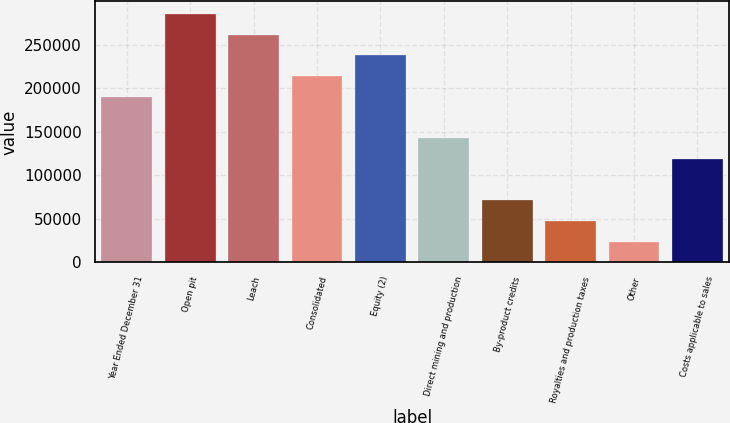Convert chart to OTSL. <chart><loc_0><loc_0><loc_500><loc_500><bar_chart><fcel>Year Ended December 31<fcel>Open pit<fcel>Leach<fcel>Consolidated<fcel>Equity (2)<fcel>Direct mining and production<fcel>By-product credits<fcel>Royalties and production taxes<fcel>Other<fcel>Costs applicable to sales<nl><fcel>190347<fcel>285519<fcel>261726<fcel>214140<fcel>237933<fcel>142761<fcel>71381.3<fcel>47588.2<fcel>23795.1<fcel>118968<nl></chart> 